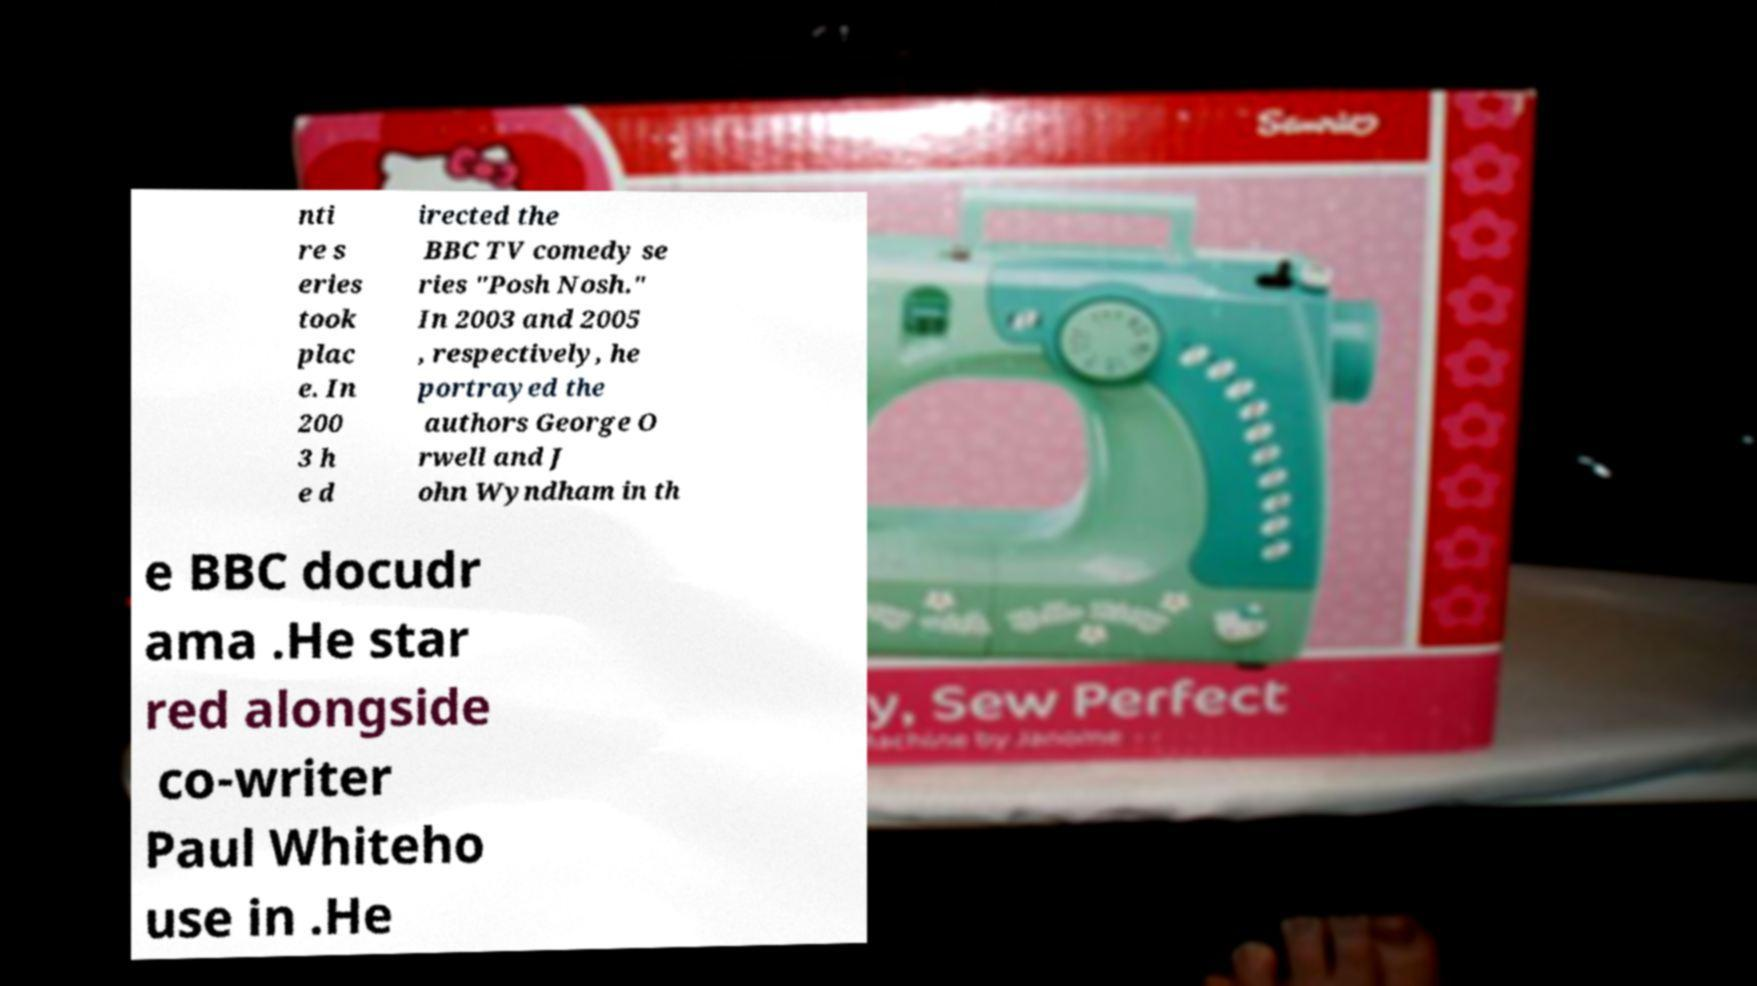There's text embedded in this image that I need extracted. Can you transcribe it verbatim? nti re s eries took plac e. In 200 3 h e d irected the BBC TV comedy se ries "Posh Nosh." In 2003 and 2005 , respectively, he portrayed the authors George O rwell and J ohn Wyndham in th e BBC docudr ama .He star red alongside co-writer Paul Whiteho use in .He 